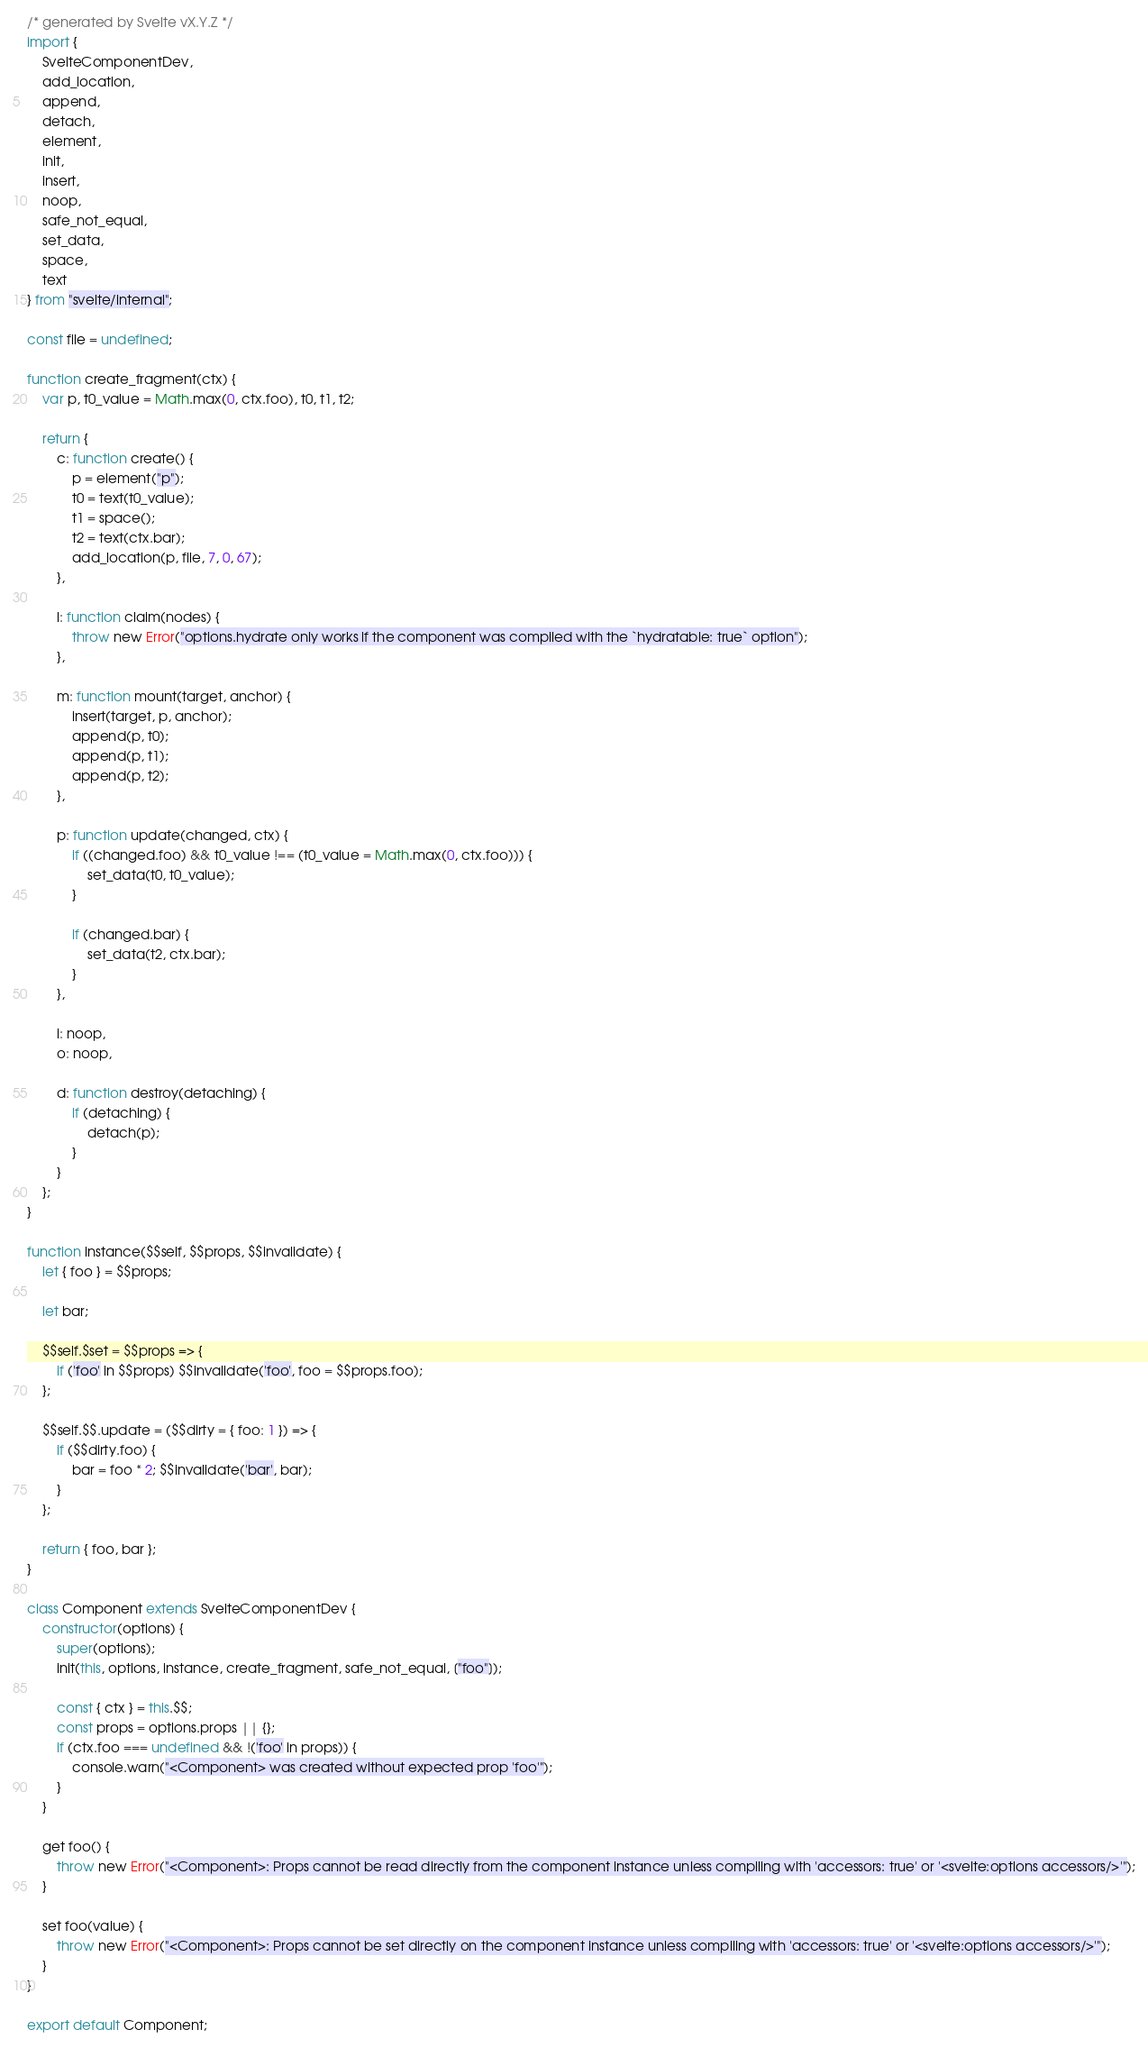<code> <loc_0><loc_0><loc_500><loc_500><_JavaScript_>/* generated by Svelte vX.Y.Z */
import {
	SvelteComponentDev,
	add_location,
	append,
	detach,
	element,
	init,
	insert,
	noop,
	safe_not_equal,
	set_data,
	space,
	text
} from "svelte/internal";

const file = undefined;

function create_fragment(ctx) {
	var p, t0_value = Math.max(0, ctx.foo), t0, t1, t2;

	return {
		c: function create() {
			p = element("p");
			t0 = text(t0_value);
			t1 = space();
			t2 = text(ctx.bar);
			add_location(p, file, 7, 0, 67);
		},

		l: function claim(nodes) {
			throw new Error("options.hydrate only works if the component was compiled with the `hydratable: true` option");
		},

		m: function mount(target, anchor) {
			insert(target, p, anchor);
			append(p, t0);
			append(p, t1);
			append(p, t2);
		},

		p: function update(changed, ctx) {
			if ((changed.foo) && t0_value !== (t0_value = Math.max(0, ctx.foo))) {
				set_data(t0, t0_value);
			}

			if (changed.bar) {
				set_data(t2, ctx.bar);
			}
		},

		i: noop,
		o: noop,

		d: function destroy(detaching) {
			if (detaching) {
				detach(p);
			}
		}
	};
}

function instance($$self, $$props, $$invalidate) {
	let { foo } = $$props;

	let bar;

	$$self.$set = $$props => {
		if ('foo' in $$props) $$invalidate('foo', foo = $$props.foo);
	};

	$$self.$$.update = ($$dirty = { foo: 1 }) => {
		if ($$dirty.foo) {
			bar = foo * 2; $$invalidate('bar', bar);
		}
	};

	return { foo, bar };
}

class Component extends SvelteComponentDev {
	constructor(options) {
		super(options);
		init(this, options, instance, create_fragment, safe_not_equal, ["foo"]);

		const { ctx } = this.$$;
		const props = options.props || {};
		if (ctx.foo === undefined && !('foo' in props)) {
			console.warn("<Component> was created without expected prop 'foo'");
		}
	}

	get foo() {
		throw new Error("<Component>: Props cannot be read directly from the component instance unless compiling with 'accessors: true' or '<svelte:options accessors/>'");
	}

	set foo(value) {
		throw new Error("<Component>: Props cannot be set directly on the component instance unless compiling with 'accessors: true' or '<svelte:options accessors/>'");
	}
}

export default Component;</code> 